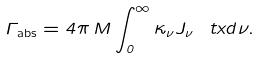<formula> <loc_0><loc_0><loc_500><loc_500>\Gamma _ { \text {abs} } = 4 \pi \, M \int _ { 0 } ^ { \infty } \kappa _ { \nu } J _ { \nu } \ t x d \nu .</formula> 